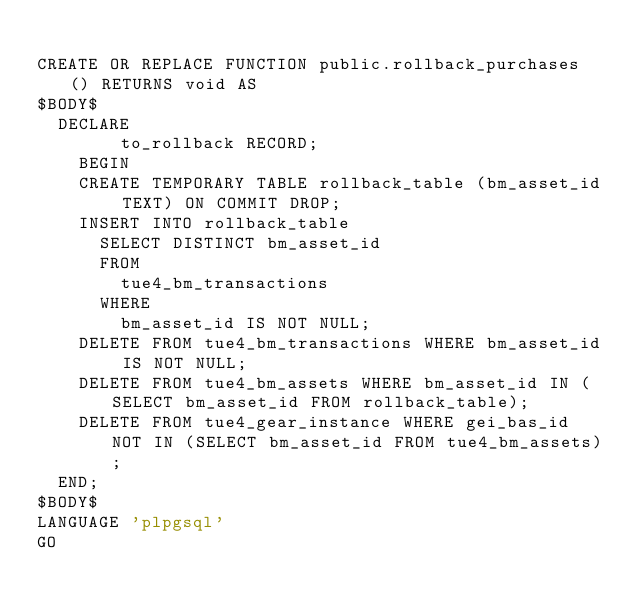Convert code to text. <code><loc_0><loc_0><loc_500><loc_500><_SQL_>
CREATE OR REPLACE FUNCTION public.rollback_purchases () RETURNS void AS
$BODY$
  DECLARE
        to_rollback RECORD;
    BEGIN
    CREATE TEMPORARY TABLE rollback_table (bm_asset_id TEXT) ON COMMIT DROP;
    INSERT INTO rollback_table
      SELECT DISTINCT bm_asset_id 
      FROM
        tue4_bm_transactions
      WHERE
        bm_asset_id IS NOT NULL;
    DELETE FROM tue4_bm_transactions WHERE bm_asset_id IS NOT NULL;
    DELETE FROM tue4_bm_assets WHERE bm_asset_id IN (SELECT bm_asset_id FROM rollback_table);
    DELETE FROM tue4_gear_instance WHERE gei_bas_id NOT IN (SELECT bm_asset_id FROM tue4_bm_assets);
  END;
$BODY$
LANGUAGE 'plpgsql'
GO
</code> 